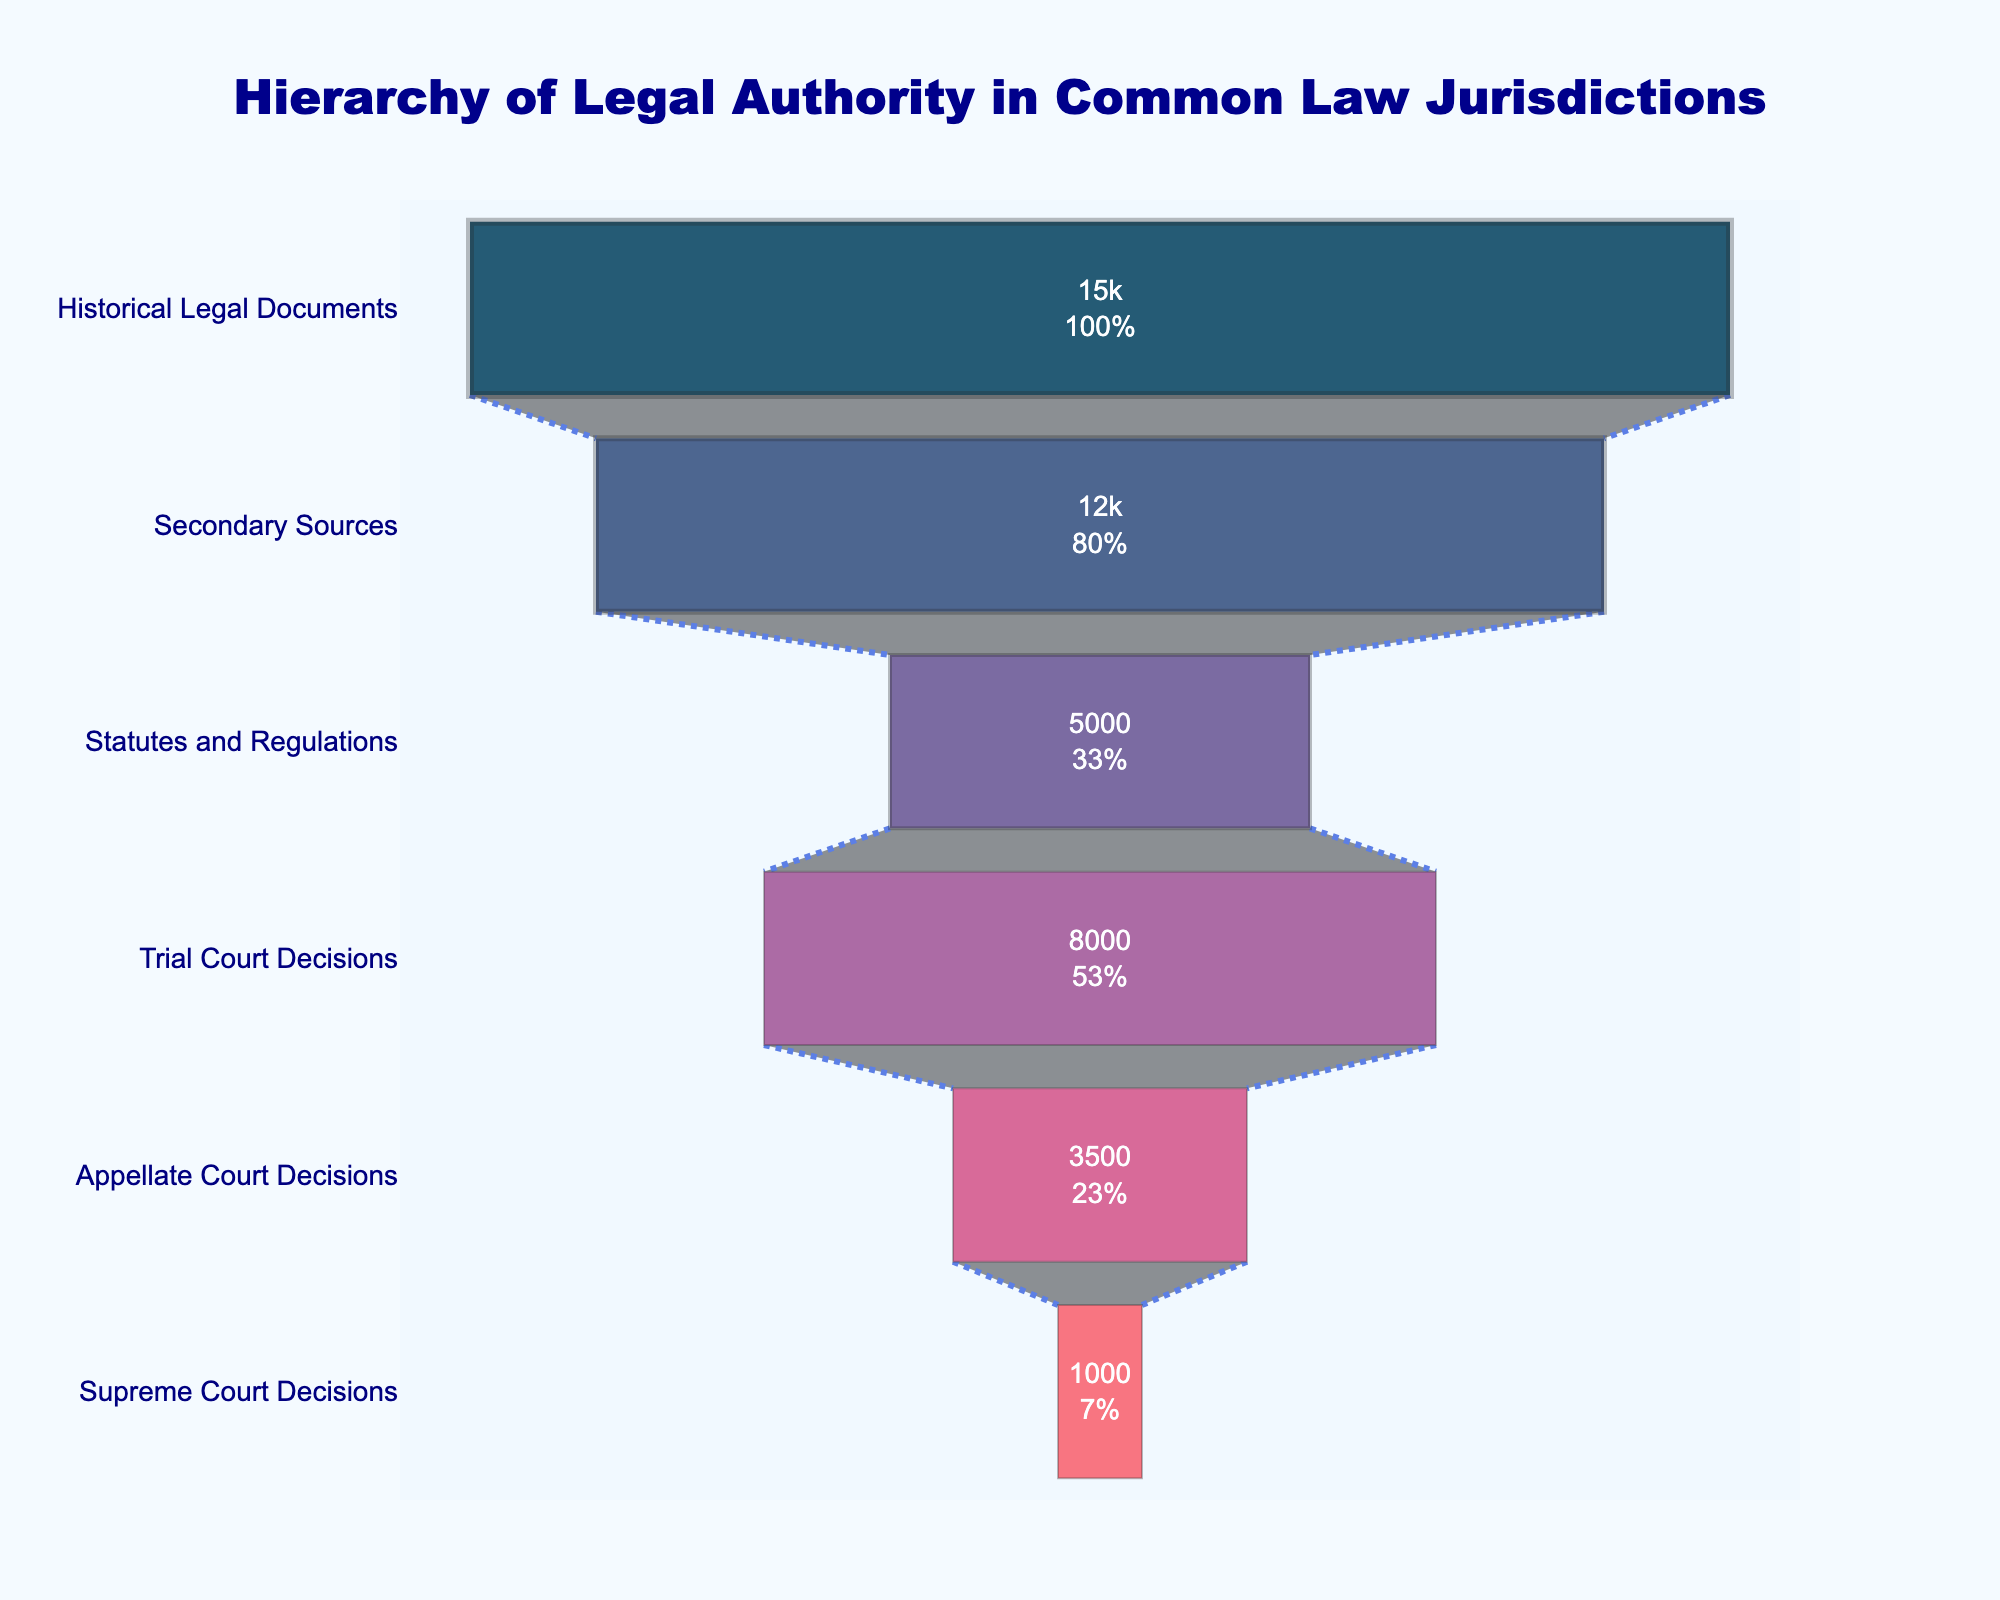What is the title of the figure? The title is typically displayed at the top of the figure, in this case, it reads "Hierarchy of Legal Authority in Common Law Jurisdictions".
Answer: Hierarchy of Legal Authority in Common Law Jurisdictions What stages are included in the funnel chart? The stages are usually labeled on the y-axis or within each segment of the funnel chart. Here, the stages include Supreme Court Decisions, Appellate Court Decisions, Trial Court Decisions, Statutes and Regulations, Secondary Sources, Historical Legal Documents.
Answer: Supreme Court Decisions, Appellate Court Decisions, Trial Court Decisions, Statutes and Regulations, Secondary Sources, Historical Legal Documents Which stage has the highest number of sources? The width of each section in a funnel chart represents the number of sources. The widest section, which is at the bottom, represents the Historical Legal Documents.
Answer: Historical Legal Documents What is the color used for the Supreme Court Decisions section? The figure's legend or color distribution indicates that the section for Supreme Court Decisions is at the top, with the color assigned being a dark shade, specifically "#003f5c".
Answer: Dark blue What percent of the initial number of sources do Secondary Sources represent? The text inside each funnel segment generally shows the percentage of the total sources. Secondary Sources are next to the bottom but one, which shows its percent of the total.
Answer: Found within the figure near this section What is the difference in the number of sources between Trial Court Decisions and Appellate Court Decisions? To find the difference, subtract the number of sources of Appellate Court Decisions (3500) from Trial Court Decisions (8000). So, 8000 - 3500 = 4500.
Answer: 4500 How many more sources do Secondary Sources have compared to Supreme Court Decisions? Subtract the number of Supreme Court Decisions (1000) from Secondary Sources (12000). So, 12000 - 1000 = 11000.
Answer: 11000 Which has more sources: Statutes and Regulations or Trial Court Decisions? Compare the values of Statutes and Regulations (5000) with Trial Court Decisions (8000). Trial Court Decisions have more sources.
Answer: Trial Court Decisions What is the total number of sources indicated in the funnel chart? Add the numbers from all stages: 1000 (Supreme Court) + 3500 (Appellate Court) + 8000 (Trial Court) + 5000 (Statutes) + 12000 (Secondary Sources) + 15000 (Historical Documents). The sum is 44500.
Answer: 44500 Which segment has a wider line marker? The line width varies at each segment, and the Supreme Court Decisions are mentioned to have the widest line marker. Thus, it should be at the top with the most prominent wider line width.
Answer: Supreme Court Decisions 